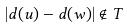Convert formula to latex. <formula><loc_0><loc_0><loc_500><loc_500>| d ( u ) - d ( w ) | \notin T</formula> 